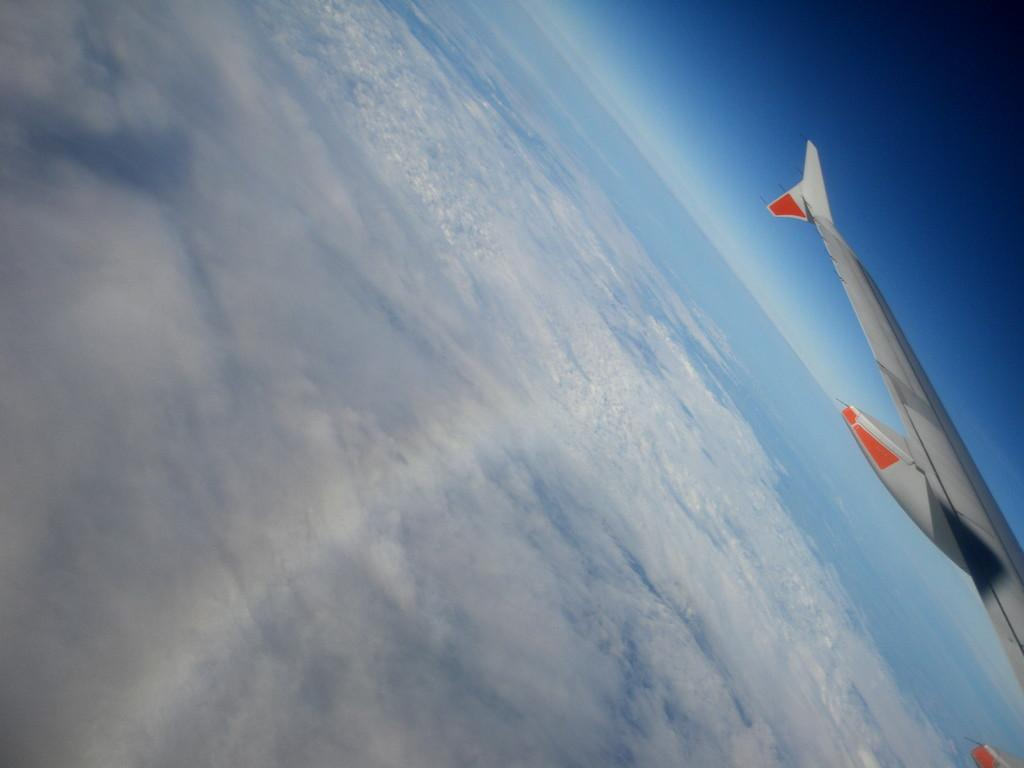What is flying in the sky in the image? There is an aircraft in the sky in the image. What else can be seen in the sky besides the aircraft? There are clouds visible in the image. What type of breakfast is being prepared on the wing of the aircraft? There is no breakfast or any indication of food preparation in the image; it only features an aircraft in the sky and clouds. 